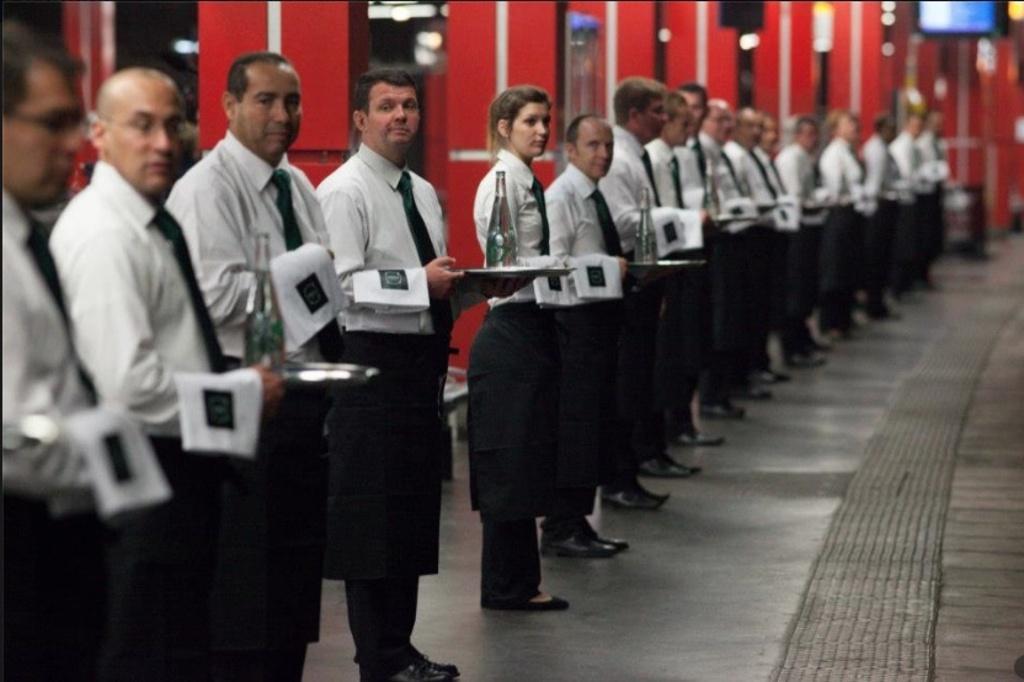Could you give a brief overview of what you see in this image? In this image we can see a group of people standing and holding objects. Behind the persons we can see few pillars. On the top right, we can see a screen. 